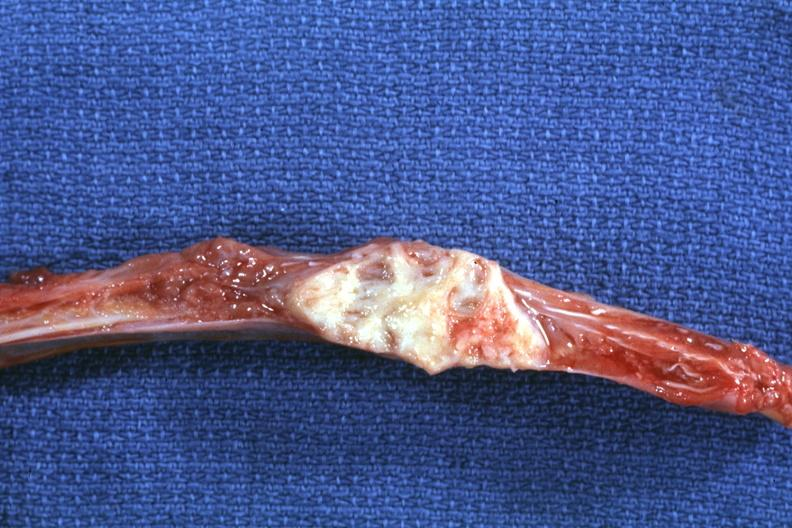what does this image show?
Answer the question using a single word or phrase. Rib with well shown lesion 